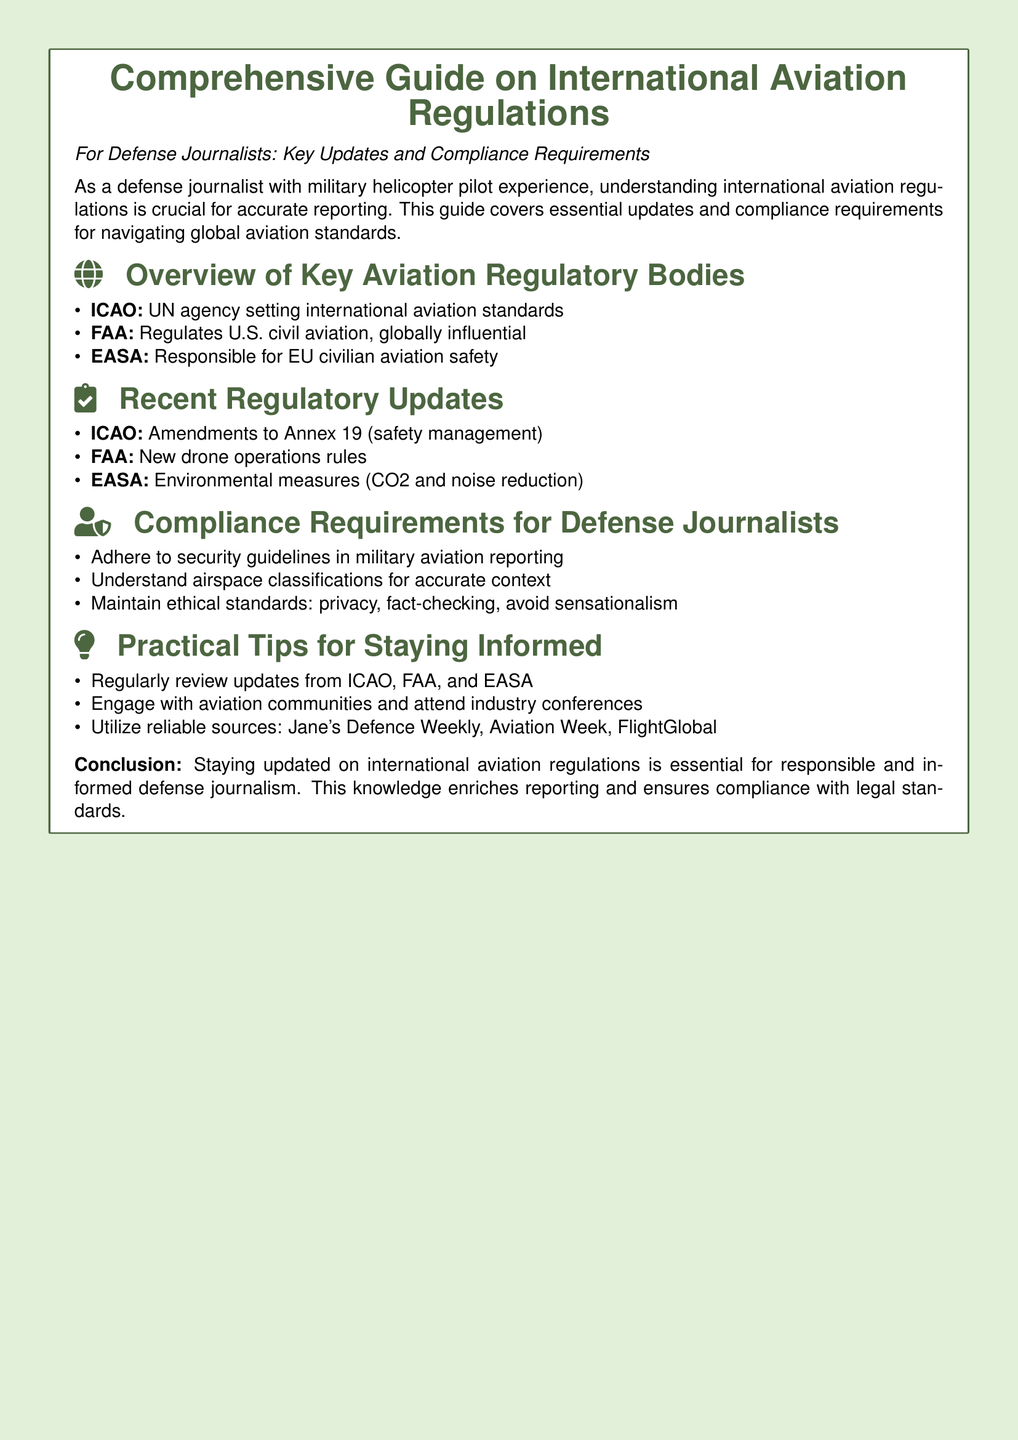What is the title of the document? The title is explicitly stated at the beginning of the document, which is "Comprehensive Guide on International Aviation Regulations."
Answer: Comprehensive Guide on International Aviation Regulations Who regulates U.S. civil aviation? The document specifies that the FAA is responsible for regulating U.S. civil aviation.
Answer: FAA What does ICAO stand for? The document provides the full form of the abbreviation ICAO, referring to an important regulatory body.
Answer: International Civil Aviation Organization What is a recent amendment made by ICAO? The document cites the specific amendment related to safety management in Annex 19.
Answer: Amendments to Annex 19 Name one environmental measure taken by EASA. The document mentions CO2 and noise reduction as environmental measures implemented by EASA.
Answer: CO2 and noise reduction What is a compliance requirement for defense journalists? The document lists various compliance requirements for defense journalists, one of which is specifically mentioned.
Answer: Adhere to security guidelines What is a suggested source for aviation updates? The document outlines several reliable sources, and one of these sources is particularly noted for defense news.
Answer: Jane's Defence Weekly Which organization is responsible for civilian aviation safety in the EU? The document clearly states that EASA is the organization for EU civilian aviation safety.
Answer: EASA What should defense journalists maintain in their reporting? The document highlights the ethical aspect of journalism that defense journalists should uphold.
Answer: Ethical standards 